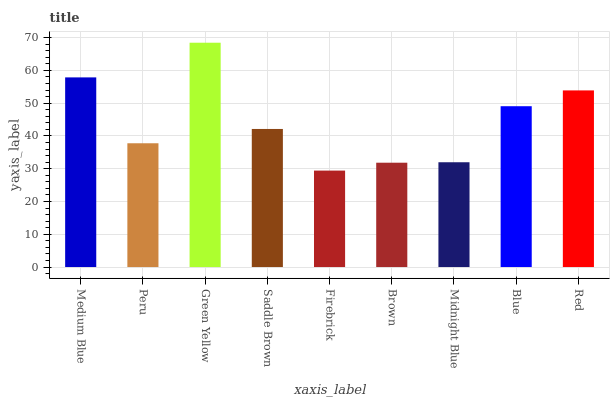Is Firebrick the minimum?
Answer yes or no. Yes. Is Green Yellow the maximum?
Answer yes or no. Yes. Is Peru the minimum?
Answer yes or no. No. Is Peru the maximum?
Answer yes or no. No. Is Medium Blue greater than Peru?
Answer yes or no. Yes. Is Peru less than Medium Blue?
Answer yes or no. Yes. Is Peru greater than Medium Blue?
Answer yes or no. No. Is Medium Blue less than Peru?
Answer yes or no. No. Is Saddle Brown the high median?
Answer yes or no. Yes. Is Saddle Brown the low median?
Answer yes or no. Yes. Is Brown the high median?
Answer yes or no. No. Is Peru the low median?
Answer yes or no. No. 